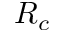Convert formula to latex. <formula><loc_0><loc_0><loc_500><loc_500>R _ { c }</formula> 